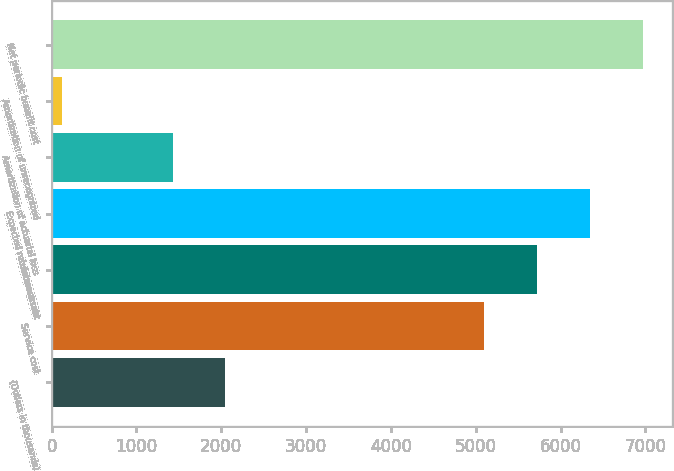<chart> <loc_0><loc_0><loc_500><loc_500><bar_chart><fcel>(Dollars in thousands)<fcel>Service cost<fcel>Interest cost<fcel>Expected return on assets<fcel>Amortization of actuarial loss<fcel>Amortization of unrecognized<fcel>Net periodic benefit cost<nl><fcel>2049.6<fcel>5096<fcel>5720.6<fcel>6345.2<fcel>1425<fcel>126<fcel>6969.8<nl></chart> 